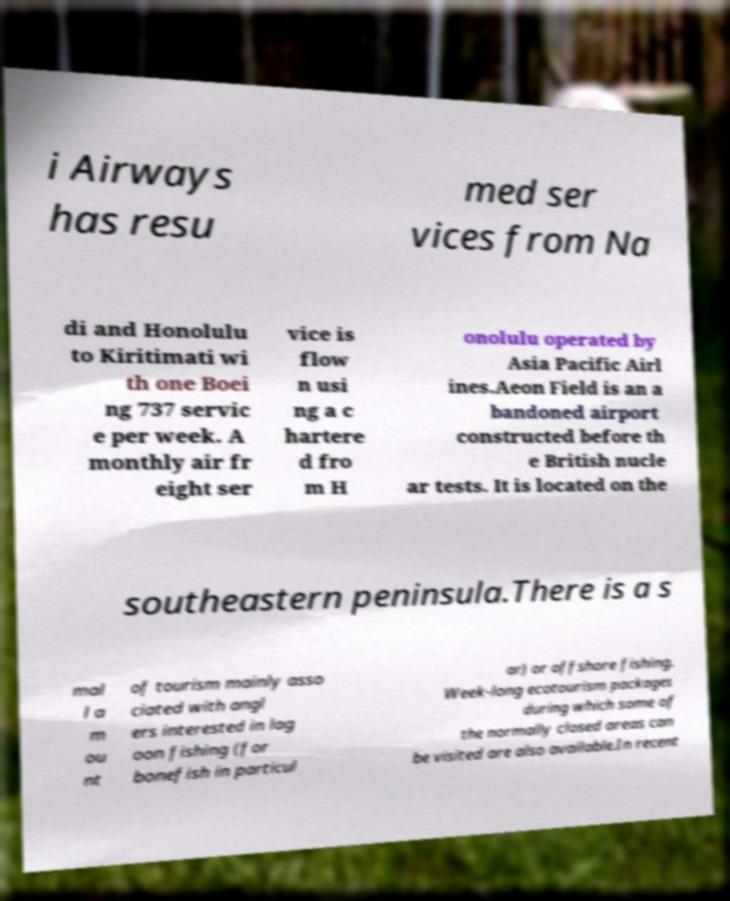Could you extract and type out the text from this image? i Airways has resu med ser vices from Na di and Honolulu to Kiritimati wi th one Boei ng 737 servic e per week. A monthly air fr eight ser vice is flow n usi ng a c hartere d fro m H onolulu operated by Asia Pacific Airl ines.Aeon Field is an a bandoned airport constructed before th e British nucle ar tests. It is located on the southeastern peninsula.There is a s mal l a m ou nt of tourism mainly asso ciated with angl ers interested in lag oon fishing (for bonefish in particul ar) or offshore fishing. Week-long ecotourism packages during which some of the normally closed areas can be visited are also available.In recent 